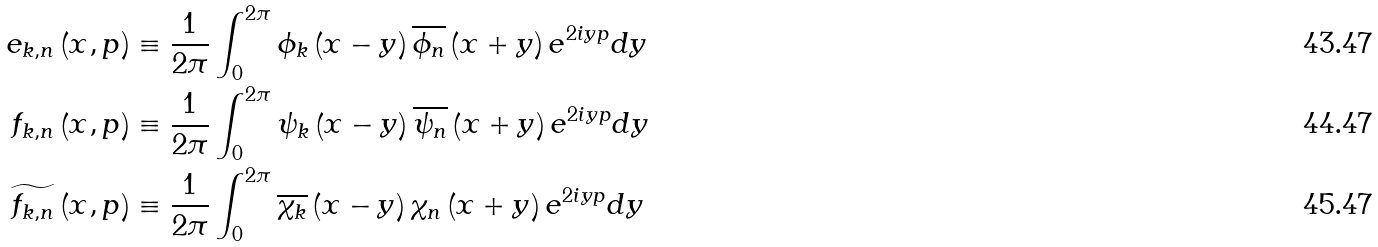Convert formula to latex. <formula><loc_0><loc_0><loc_500><loc_500>e _ { k , n } \left ( x , p \right ) & \equiv \frac { 1 } { 2 \pi } \int _ { 0 } ^ { 2 \pi } \phi _ { k } \left ( x - y \right ) \overline { \phi _ { n } } \left ( x + y \right ) e ^ { 2 i y p } d y \\ f _ { k , n } \left ( x , p \right ) & \equiv \frac { 1 } { 2 \pi } \int _ { 0 } ^ { 2 \pi } \psi _ { k } \left ( x - y \right ) \overline { \psi _ { n } } \left ( x + y \right ) e ^ { 2 i y p } d y \\ \widetilde { f _ { k , n } } \left ( x , p \right ) & \equiv \frac { 1 } { 2 \pi } \int _ { 0 } ^ { 2 \pi } \overline { \chi _ { k } } \left ( x - y \right ) \chi _ { n } \left ( x + y \right ) e ^ { 2 i y p } d y</formula> 